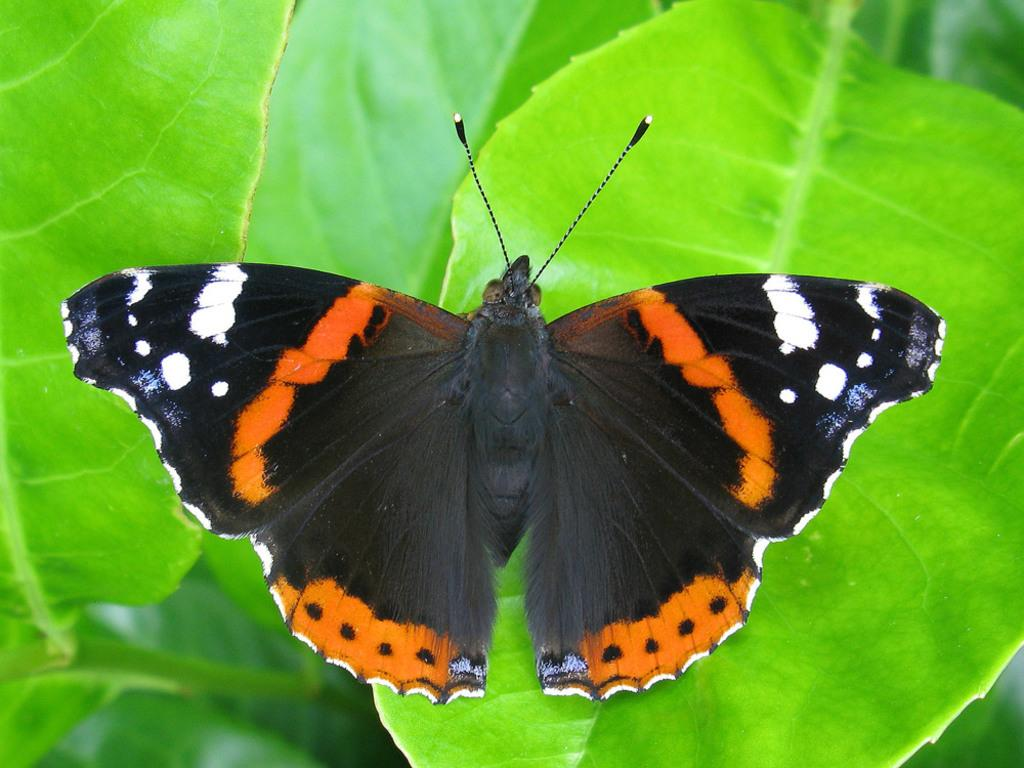What is the main subject of the image? There is a butterfly in the image. Where is the butterfly located? The butterfly is on a leaf. What type of tin can be seen in the image? There is no tin present in the image; it features a butterfly on a leaf. How many quivers are visible in the image? There are no quivers present in the image. 